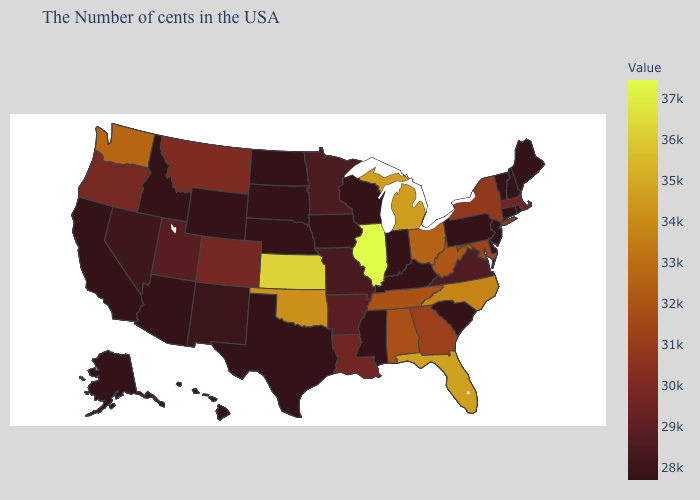Among the states that border Illinois , which have the highest value?
Concise answer only. Missouri. Which states have the lowest value in the South?
Short answer required. Delaware, South Carolina, Kentucky, Mississippi, Texas. Does Missouri have a lower value than Tennessee?
Short answer required. Yes. Does Illinois have the highest value in the MidWest?
Quick response, please. Yes. Among the states that border Colorado , which have the highest value?
Quick response, please. Kansas. Among the states that border Tennessee , which have the lowest value?
Quick response, please. Kentucky, Mississippi. Which states hav the highest value in the West?
Short answer required. Washington. 